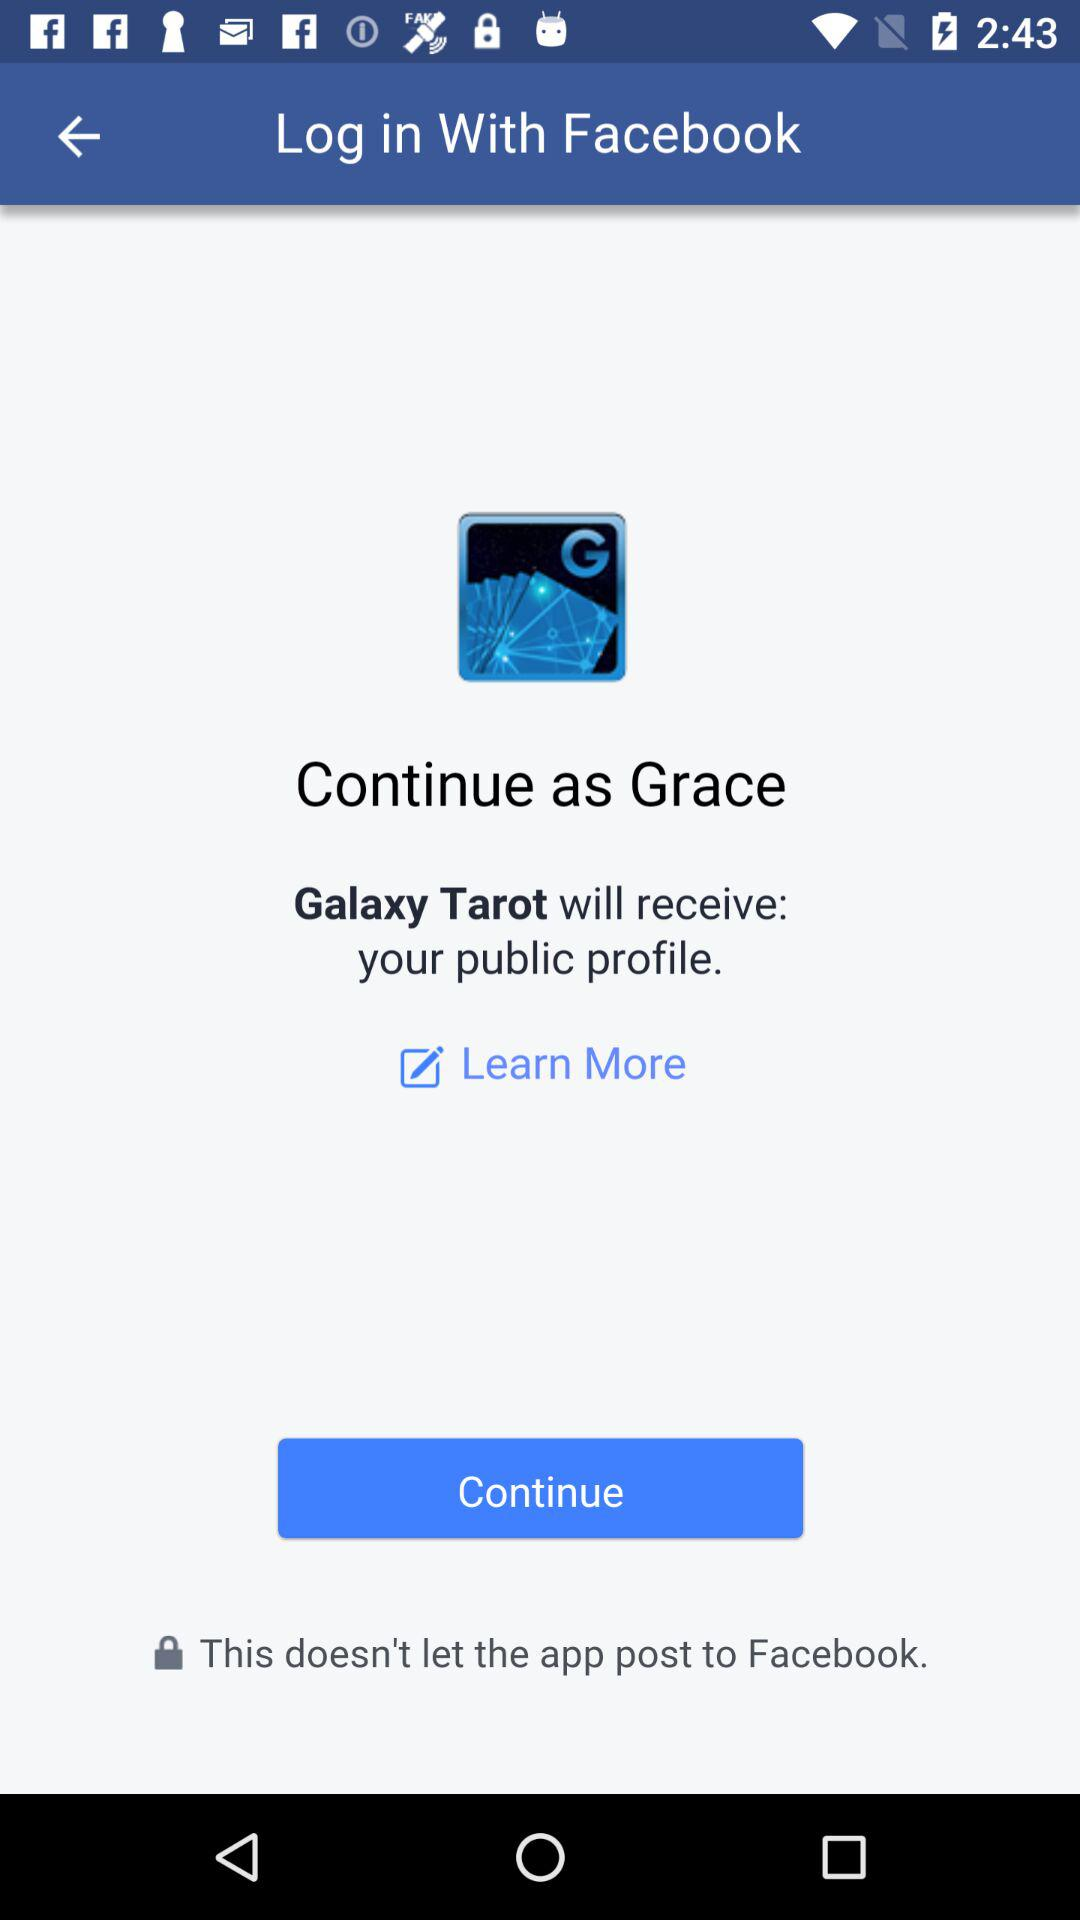What is the application that will have access to the public profile? The application that will have access to the public profile is "Galaxy Tarot". 